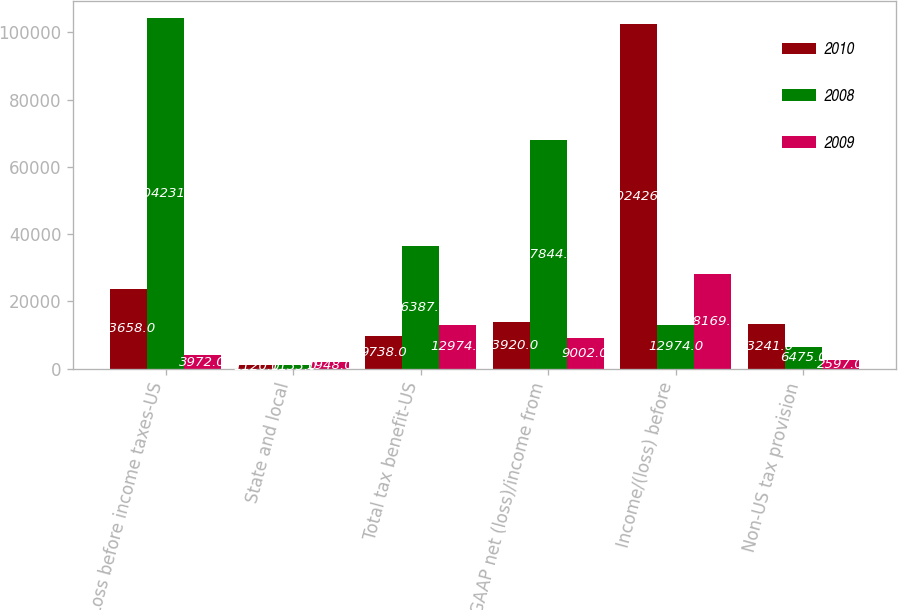Convert chart. <chart><loc_0><loc_0><loc_500><loc_500><stacked_bar_chart><ecel><fcel>Loss before income taxes-US<fcel>State and local<fcel>Total tax benefit-US<fcel>GAAP net (loss)/income from<fcel>Income/(loss) before<fcel>Non-US tax provision<nl><fcel>2010<fcel>23658<fcel>1120<fcel>9738<fcel>13920<fcel>102426<fcel>13241<nl><fcel>2008<fcel>104231<fcel>1133<fcel>36387<fcel>67844<fcel>12974<fcel>6475<nl><fcel>2009<fcel>3972<fcel>1948<fcel>12974<fcel>9002<fcel>28169<fcel>2597<nl></chart> 